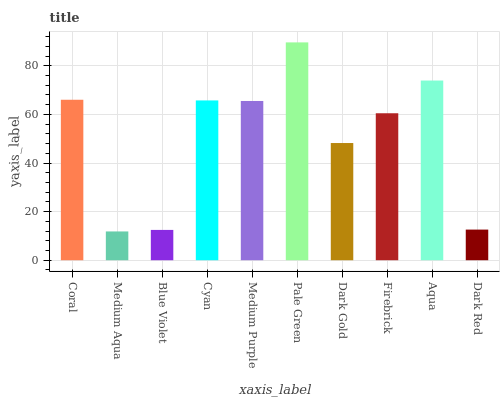Is Medium Aqua the minimum?
Answer yes or no. Yes. Is Pale Green the maximum?
Answer yes or no. Yes. Is Blue Violet the minimum?
Answer yes or no. No. Is Blue Violet the maximum?
Answer yes or no. No. Is Blue Violet greater than Medium Aqua?
Answer yes or no. Yes. Is Medium Aqua less than Blue Violet?
Answer yes or no. Yes. Is Medium Aqua greater than Blue Violet?
Answer yes or no. No. Is Blue Violet less than Medium Aqua?
Answer yes or no. No. Is Medium Purple the high median?
Answer yes or no. Yes. Is Firebrick the low median?
Answer yes or no. Yes. Is Blue Violet the high median?
Answer yes or no. No. Is Cyan the low median?
Answer yes or no. No. 